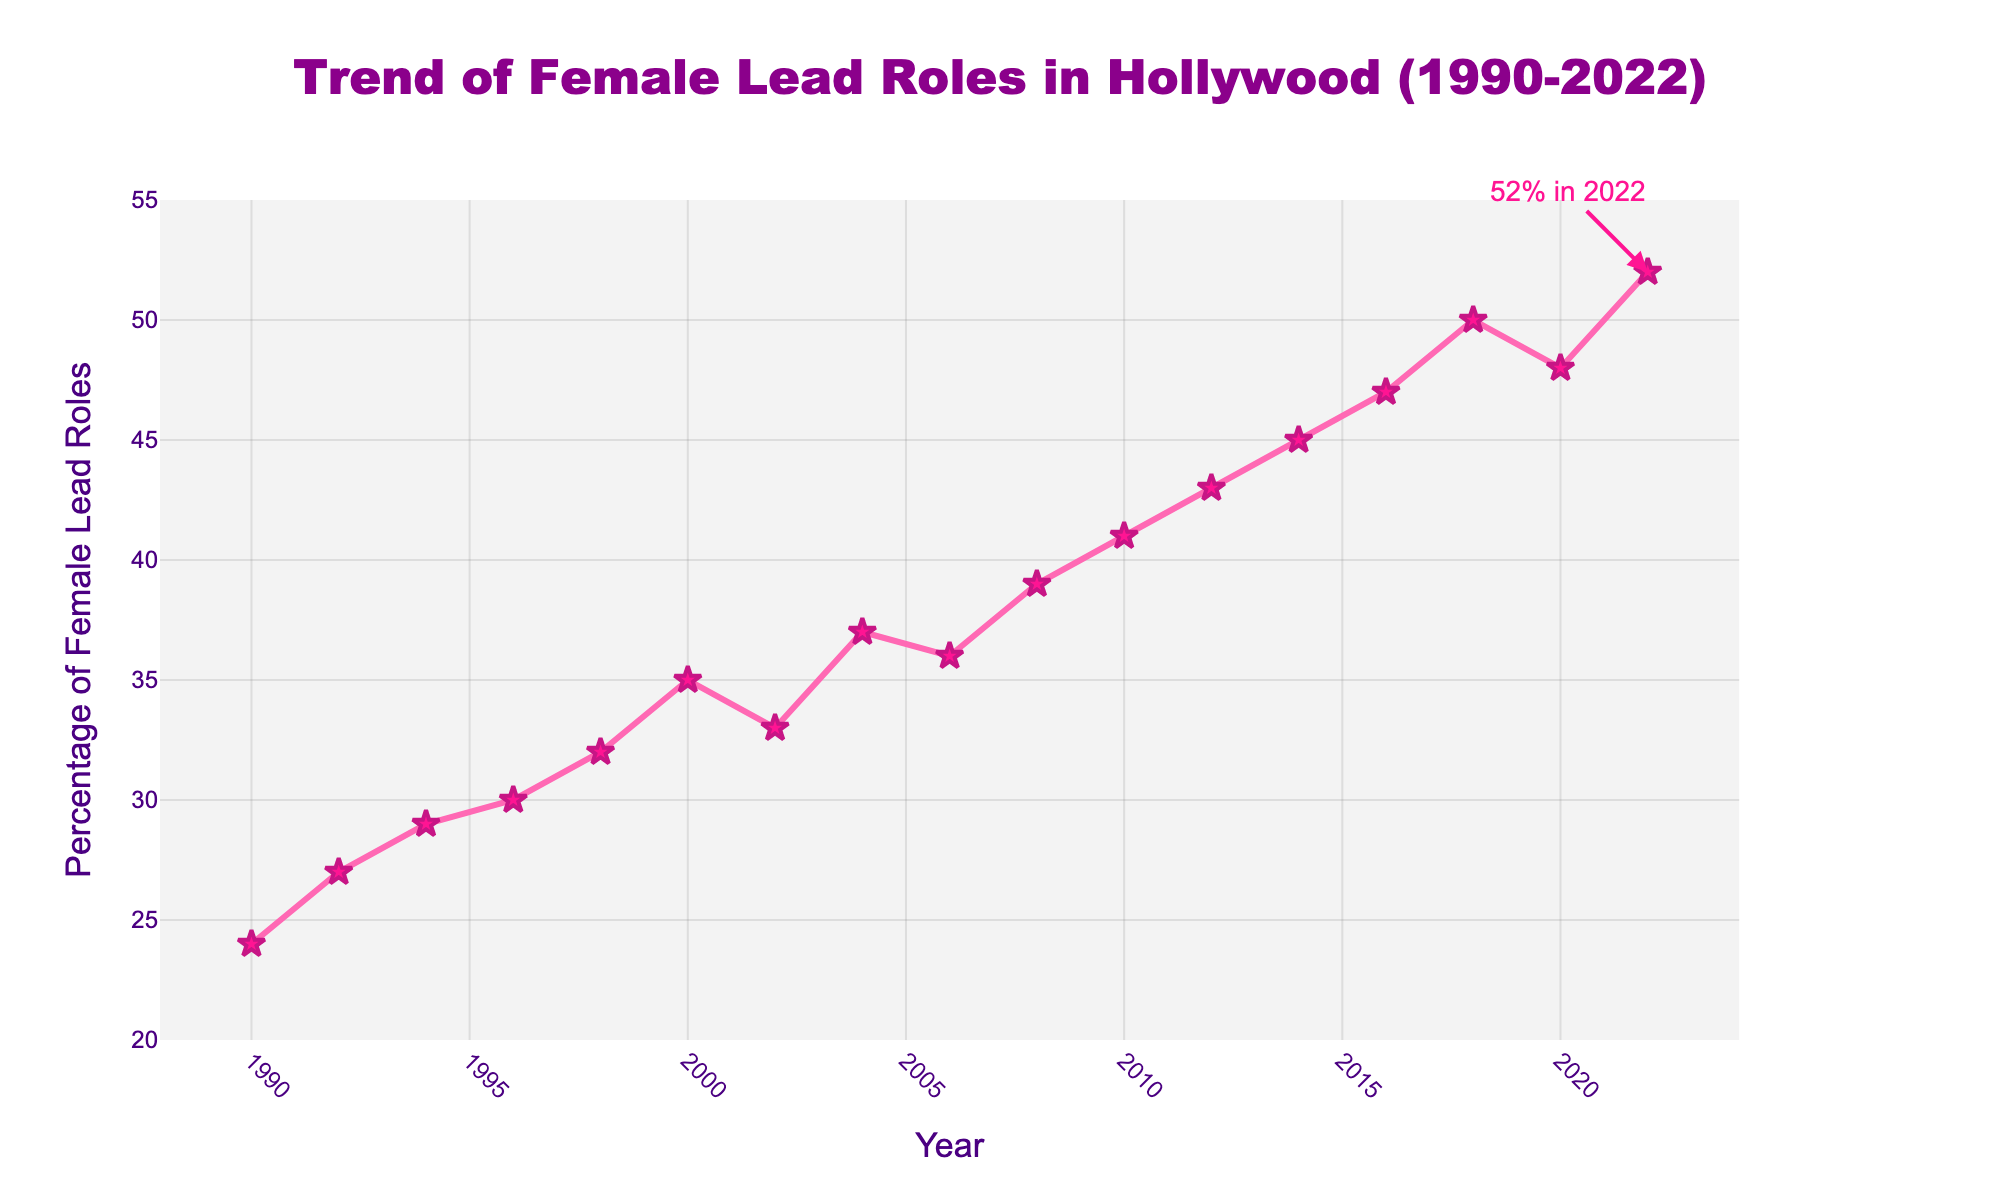What was the percentage of female lead roles in 1990? The figure shows the trend line starting at 1990 with a specific data point. The percentage of female lead roles marked there is 24%.
Answer: 24% How much did the percentage of female lead roles increase from 1998 to 2018? In 1998, the percentage is 32% and in 2018 it is 50%. The increase is calculated as 50% - 32% = 18%.
Answer: 18% Which year saw the highest percentage of female lead roles? The figure shows the peak value of female lead roles in the year 2022 at 52%.
Answer: 2022 Compare the percentage increase between 1990 to 2000 and 2000 to 2010. Which period experienced a larger increase? From 1990 to 2000, the percentage increased from 24% to 35%, giving an 11% increase. From 2000 to 2010, it increased from 35% to 41%, giving a 6% increase. Thus, 1990 to 2000 experienced a larger increase.
Answer: 1990 to 2000 What was the percentage change in female lead roles between the years 2014 and 2016? In 2014, the percentage was 45% and in 2016 it was 47%. The change is calculated as 47% - 45% = 2%.
Answer: 2% During which decade did female lead roles surpass 40% for the first time? The figure shows that the female lead roles surpassed 40% for the first time in 2010.
Answer: 2010s What is the average percentage of female lead roles for the years 2004 to 2012? The percentages are 37%, 36%, 39%, 41%, and 43% for 2004, 2006, 2008, 2010, and 2012 respectively. The sum of these values is 196%. The average is 196/5 = 39.2%.
Answer: 39.2% Between which consecutive years did the percentage of female lead roles decrease? The percentage of female lead roles decreased between 2000 and 2002 (35% to 33%) and between 2018 and 2020 (50% to 48%).
Answer: 2000-2002, 2018-2020 What is the difference in percentage of female lead roles between 1992 and 2022? The percentage was 27% in 1992 and 52% in 2022. The difference is calculated as 52% - 27% = 25%.
Answer: 25% Describe the trend of female lead roles from 2010 to 2022 using the line's direction in the figure. The figure shows a generally increasing trend in female lead roles from 2010 (41%) to 2022 (52%) with a slight dip around 2020.
Answer: Increasing with a slight dip around 2020 